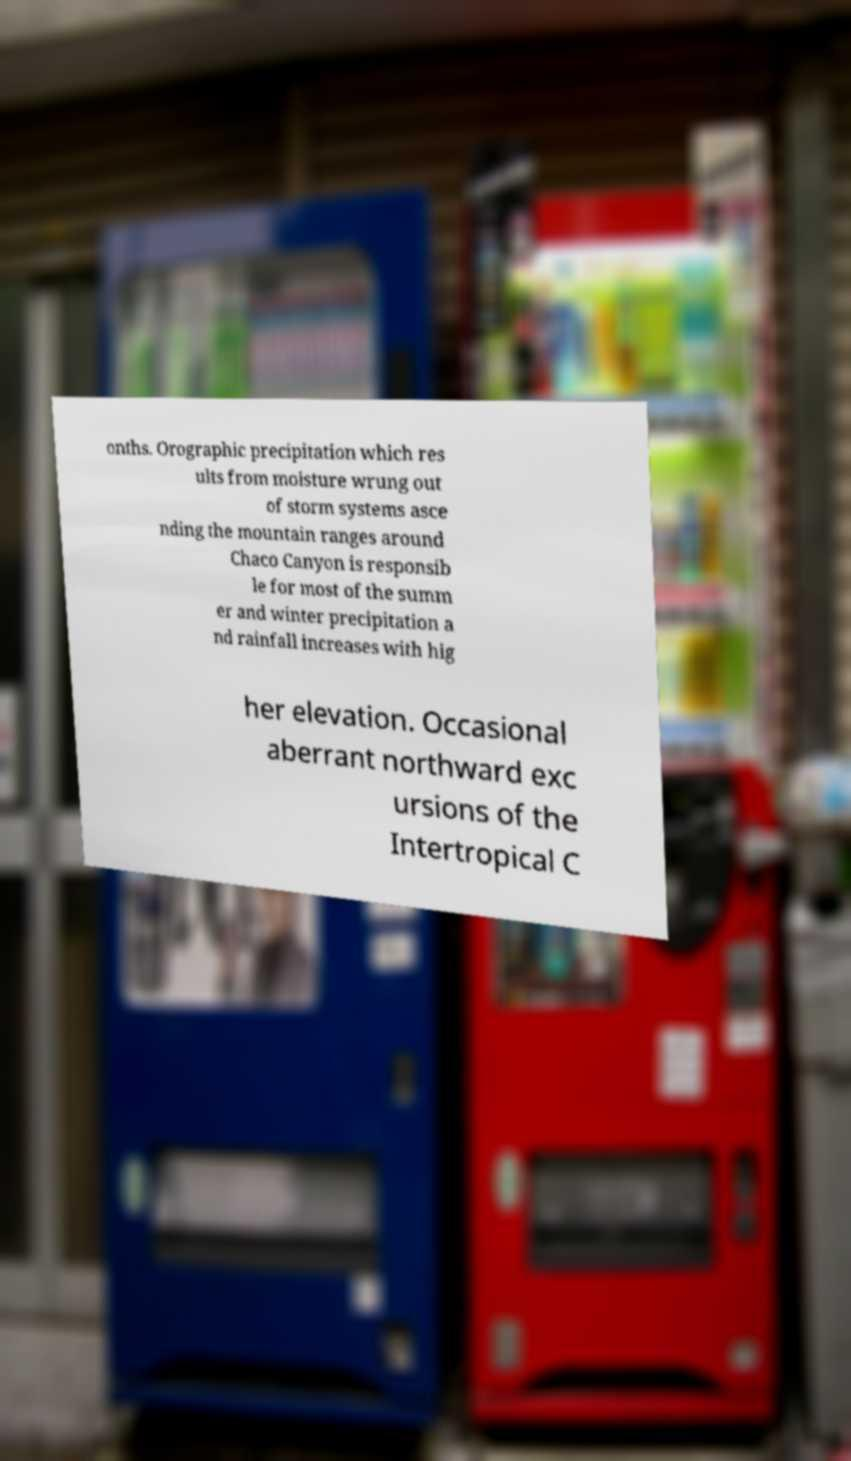Can you accurately transcribe the text from the provided image for me? onths. Orographic precipitation which res ults from moisture wrung out of storm systems asce nding the mountain ranges around Chaco Canyon is responsib le for most of the summ er and winter precipitation a nd rainfall increases with hig her elevation. Occasional aberrant northward exc ursions of the Intertropical C 